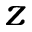Convert formula to latex. <formula><loc_0><loc_0><loc_500><loc_500>z</formula> 